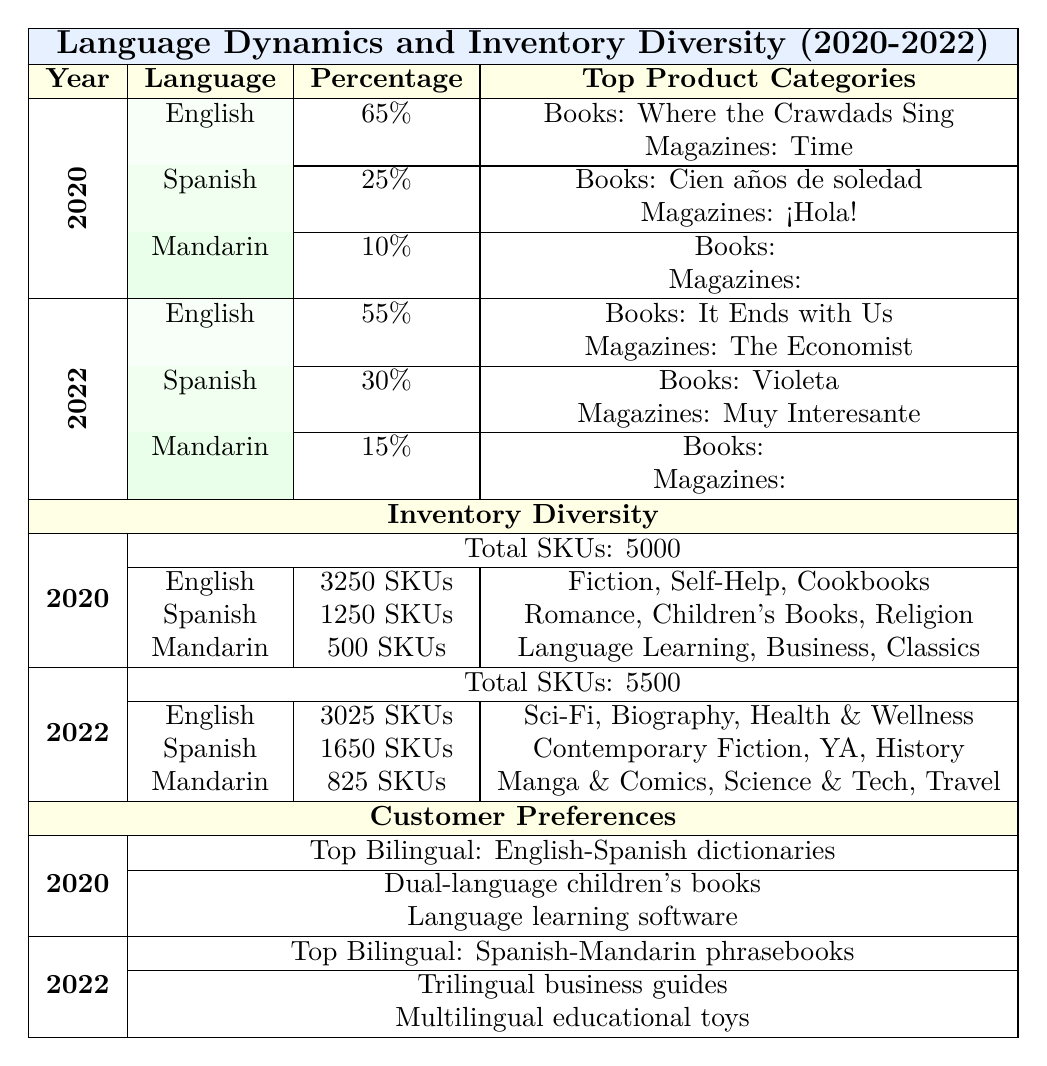What was the percentage of English speakers in 2022? In the "Language Dynamics" section, the row for 2022 shows that English had a percentage of 55%.
Answer: 55% How many total SKUs were there in 2020? The "Inventory Diversity" section for 2020 indicates there were 5000 total SKUs.
Answer: 5000 Which language had the highest number of SKUs in 2020? Looking at the SKUs for each language in 2020, English had 3250 SKUs, which is the highest compared to Spanish (1250) and Mandarin (500).
Answer: English What was the percentage increase of Spanish speakers from 2020 to 2022? In 2020, Spanish speakers made up 25%, and by 2022 this increased to 30%. The increase is 30% - 25% = 5%.
Answer: 5% How many language-specific products were there for Mandarin in 2022? In the "Inventory Diversity" section for 2022, the Mandarin row shows there were 825 language-specific products (SKUs).
Answer: 825 Which product category had the most SKUs in 2022? The English row for 2022 lists "Science Fiction, Biography, Health & Wellness", but to find the top SKU category, we need to compare across all languages. English had 3025, Spanish had 1650, and Mandarin had 825. Thus, English had the most SKUs overall.
Answer: English Was the number of SKUs for Spanish language-specific products higher in 2022 than in 2020? For Spanish, the SKUs in 2020 were 1250, and in 2022, they increased to 1650. Since 1650 is greater than 1250, the answer is yes.
Answer: Yes What are the bestselling books in Spanish for 2022? In the "Language Dynamics" section under Spanish for 2022, the bestselling books listed are "Violeta," "Como agua para chocolate," and "El amor en los tiempos del cólera."
Answer: Violeta, Como agua para chocolate, El amor en los tiempos del cólera Which new category was most requested in 2022? According to the "Customer Preferences" section for 2022, the most requested new categories were "Cultural fusion cookbooks," "Multilingual streaming services," and "Global current affairs magazines." The answer can be subjective but can focus on those mentioned.
Answer: Cultural fusion cookbooks How many SKUs were dedicated to Spanish language products in 2020 compared to 2022? For Spanish, the SKUs in 2020 were 1250, while in 2022 they increased to 1650. The difference can be calculated as 1650 - 1250 = 400.
Answer: 400 What is the total percentage of language speakers in the neighborhood in 2022? The total percentage is the sum of English (55%), Spanish (30%), and Mandarin (15%). Thus, 55% + 30% + 15% equals 100%.
Answer: 100% 